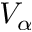<formula> <loc_0><loc_0><loc_500><loc_500>V _ { \alpha }</formula> 